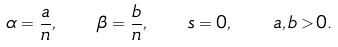<formula> <loc_0><loc_0><loc_500><loc_500>\alpha = \frac { a } { n } , \quad \beta = \frac { b } { n } , \quad s = 0 , \quad a , b > 0 .</formula> 